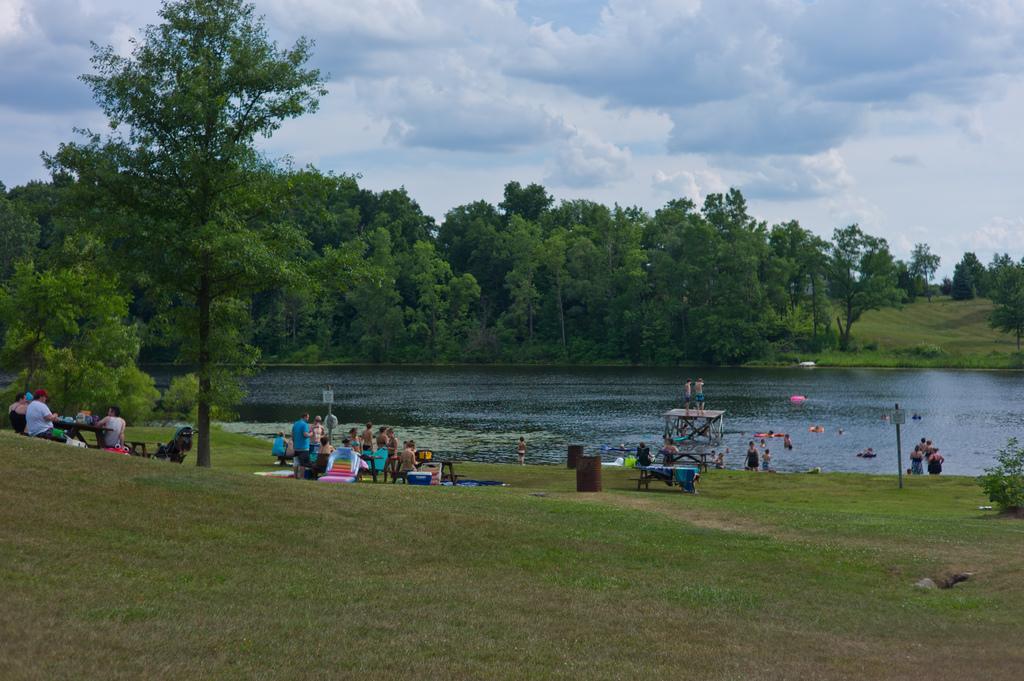Describe this image in one or two sentences. In this image I can see group of people, some are sitting and some are standing and I can see few objects on the table. In the background I can see the water and I can see few people in the water, trees in green color and the sky is in blue and white color. 